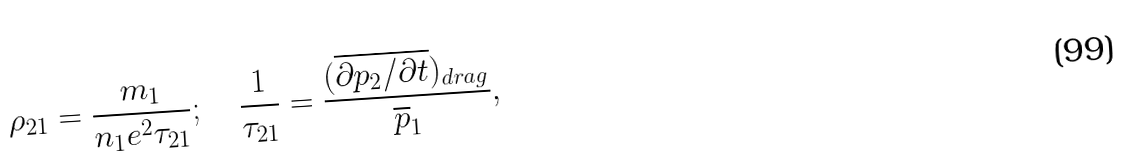<formula> <loc_0><loc_0><loc_500><loc_500>\rho _ { 2 1 } = \frac { m _ { 1 } } { n _ { 1 } e ^ { 2 } \tau _ { 2 1 } } ; \quad \frac { 1 } { \tau _ { 2 1 } } = \frac { ( \overline { { \partial p _ { 2 } } / { \partial t } } ) _ { d r a g } } { \overline { p } _ { 1 } } ,</formula> 